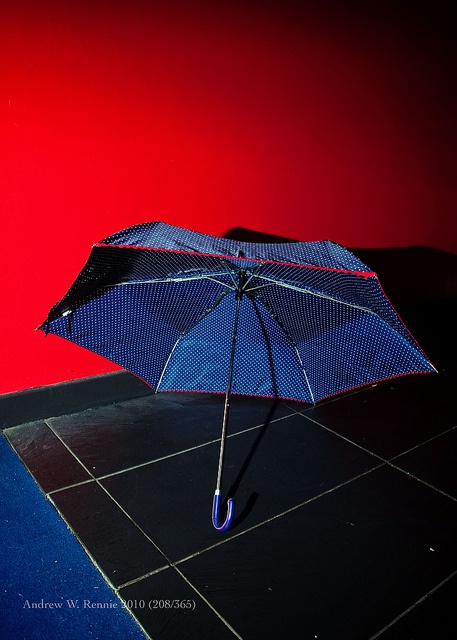Describe the objects in this image and their specific colors. I can see a umbrella in maroon, navy, black, gray, and blue tones in this image. 